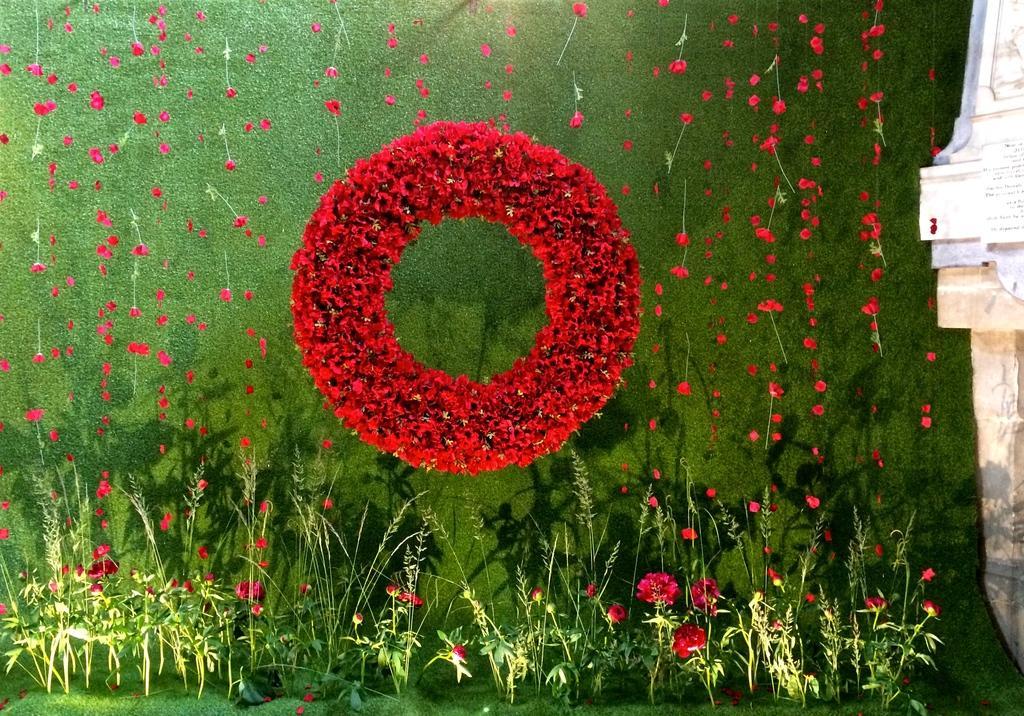Can you describe this image briefly? In this image there is a garland at the center. Behind it there is a wall painted in green color. Few flower petals are falling from the top. Bottom of image there are few plants having flowers. A lamp is on the grassland. Right side there is a pillar having few papers attached to it. 